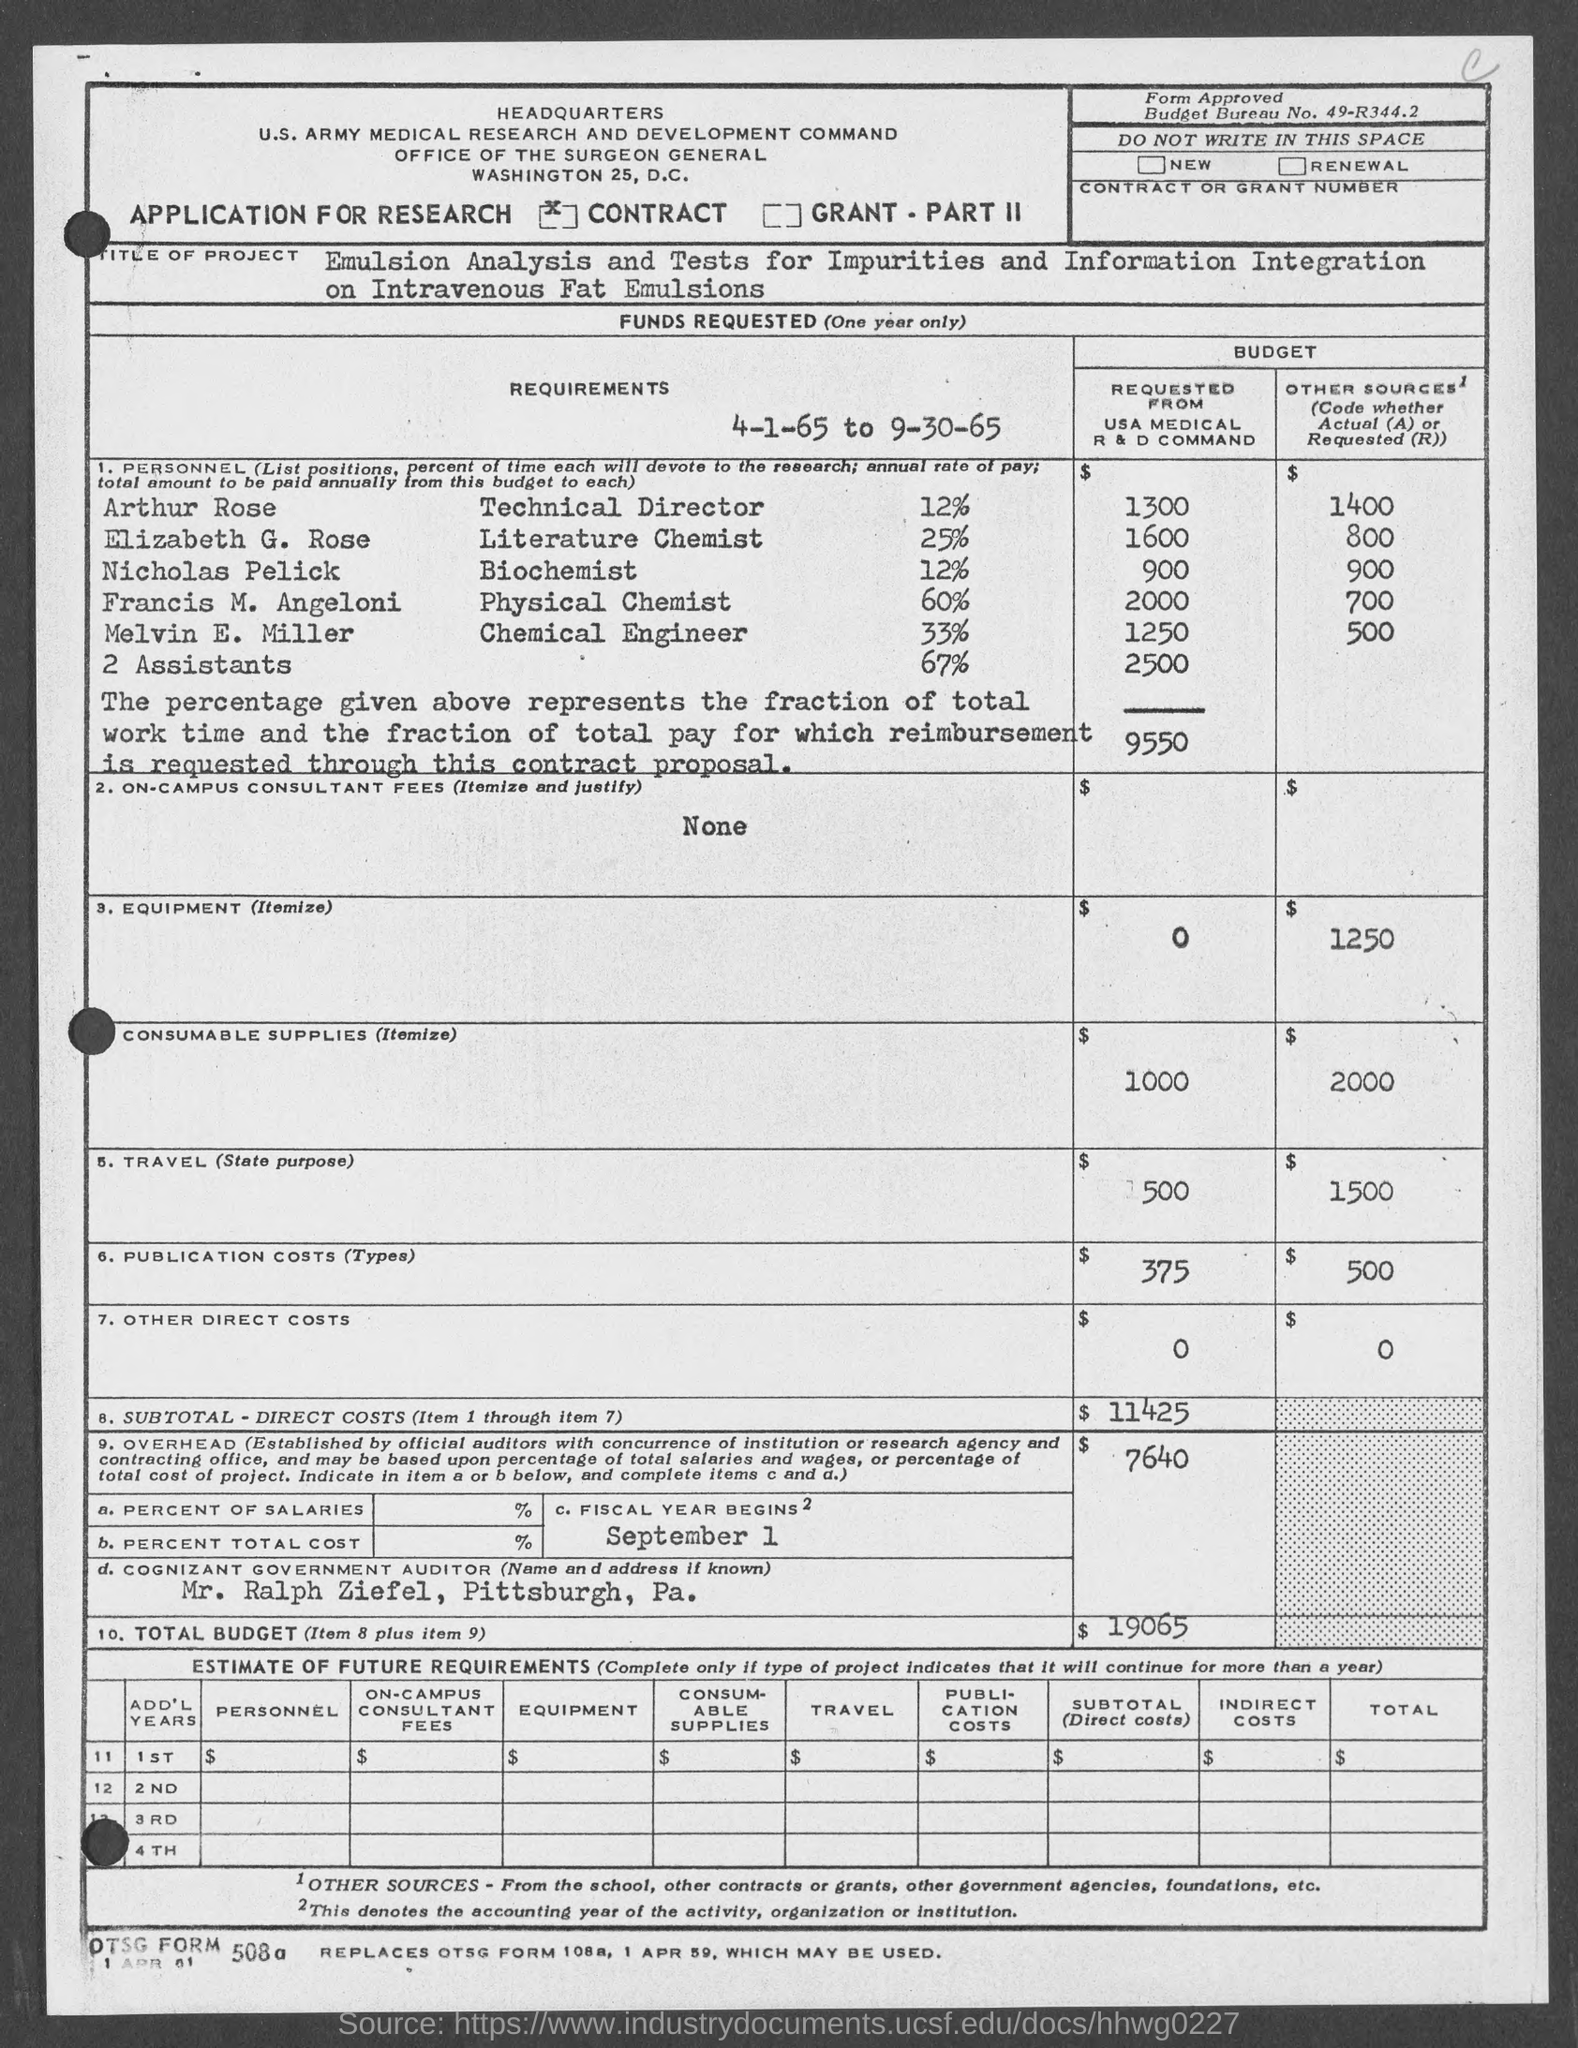Specify some key components in this picture. The budget bureau number is 49-R344.2. The cognizant government auditor is Mr. Ralph Ziefel. 